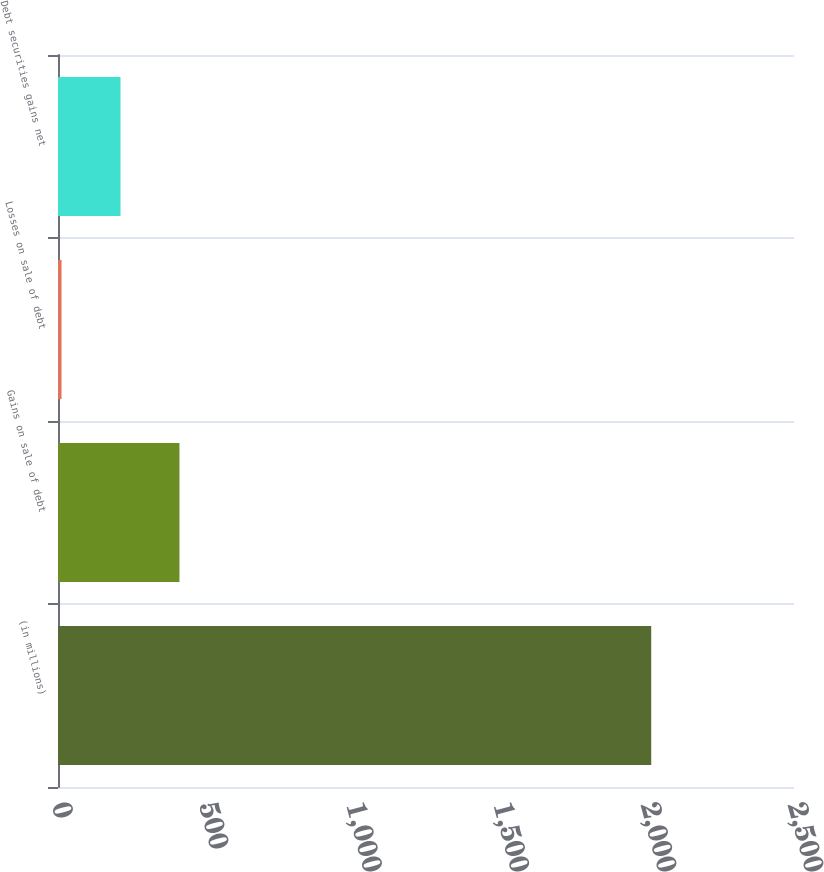Convert chart. <chart><loc_0><loc_0><loc_500><loc_500><bar_chart><fcel>(in millions)<fcel>Gains on sale of debt<fcel>Losses on sale of debt<fcel>Debt securities gains net<nl><fcel>2015<fcel>412.6<fcel>12<fcel>212.3<nl></chart> 